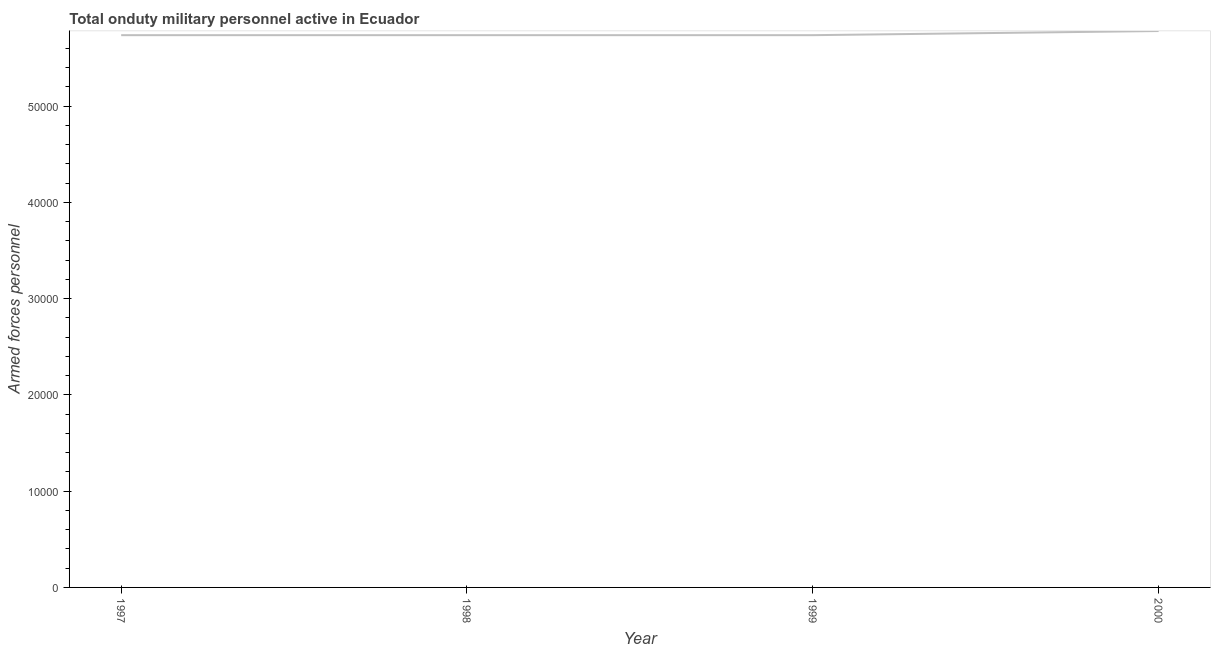What is the number of armed forces personnel in 2000?
Your response must be concise. 5.78e+04. Across all years, what is the maximum number of armed forces personnel?
Give a very brief answer. 5.78e+04. Across all years, what is the minimum number of armed forces personnel?
Make the answer very short. 5.74e+04. In which year was the number of armed forces personnel maximum?
Your answer should be very brief. 2000. What is the sum of the number of armed forces personnel?
Give a very brief answer. 2.30e+05. What is the difference between the number of armed forces personnel in 1998 and 2000?
Ensure brevity in your answer.  -430. What is the average number of armed forces personnel per year?
Offer a terse response. 5.75e+04. What is the median number of armed forces personnel?
Your answer should be very brief. 5.74e+04. In how many years, is the number of armed forces personnel greater than 48000 ?
Provide a short and direct response. 4. Do a majority of the years between 1997 and 2000 (inclusive) have number of armed forces personnel greater than 22000 ?
Provide a succinct answer. Yes. Is the number of armed forces personnel in 1997 less than that in 1998?
Your answer should be compact. No. Is the difference between the number of armed forces personnel in 1999 and 2000 greater than the difference between any two years?
Offer a very short reply. Yes. What is the difference between the highest and the second highest number of armed forces personnel?
Keep it short and to the point. 430. What is the difference between the highest and the lowest number of armed forces personnel?
Offer a terse response. 430. Does the number of armed forces personnel monotonically increase over the years?
Provide a succinct answer. No. What is the difference between two consecutive major ticks on the Y-axis?
Provide a succinct answer. 10000. Are the values on the major ticks of Y-axis written in scientific E-notation?
Provide a short and direct response. No. Does the graph contain any zero values?
Provide a short and direct response. No. What is the title of the graph?
Make the answer very short. Total onduty military personnel active in Ecuador. What is the label or title of the Y-axis?
Your answer should be very brief. Armed forces personnel. What is the Armed forces personnel in 1997?
Give a very brief answer. 5.74e+04. What is the Armed forces personnel of 1998?
Your answer should be compact. 5.74e+04. What is the Armed forces personnel of 1999?
Offer a very short reply. 5.74e+04. What is the Armed forces personnel of 2000?
Your response must be concise. 5.78e+04. What is the difference between the Armed forces personnel in 1997 and 2000?
Give a very brief answer. -430. What is the difference between the Armed forces personnel in 1998 and 2000?
Your response must be concise. -430. What is the difference between the Armed forces personnel in 1999 and 2000?
Make the answer very short. -430. What is the ratio of the Armed forces personnel in 1997 to that in 1999?
Provide a succinct answer. 1. What is the ratio of the Armed forces personnel in 1997 to that in 2000?
Your answer should be compact. 0.99. What is the ratio of the Armed forces personnel in 1998 to that in 2000?
Offer a very short reply. 0.99. What is the ratio of the Armed forces personnel in 1999 to that in 2000?
Give a very brief answer. 0.99. 